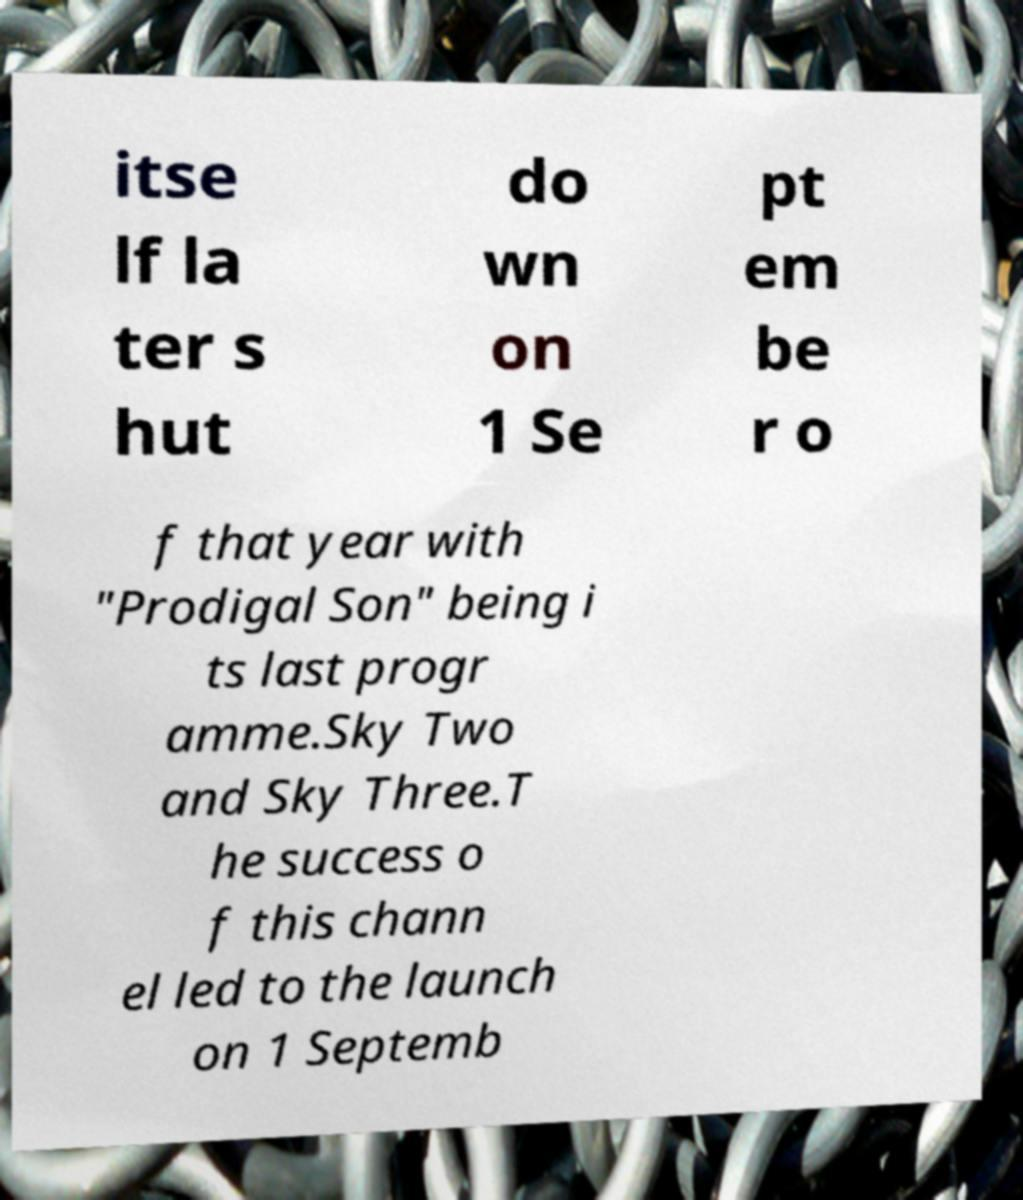There's text embedded in this image that I need extracted. Can you transcribe it verbatim? itse lf la ter s hut do wn on 1 Se pt em be r o f that year with "Prodigal Son" being i ts last progr amme.Sky Two and Sky Three.T he success o f this chann el led to the launch on 1 Septemb 